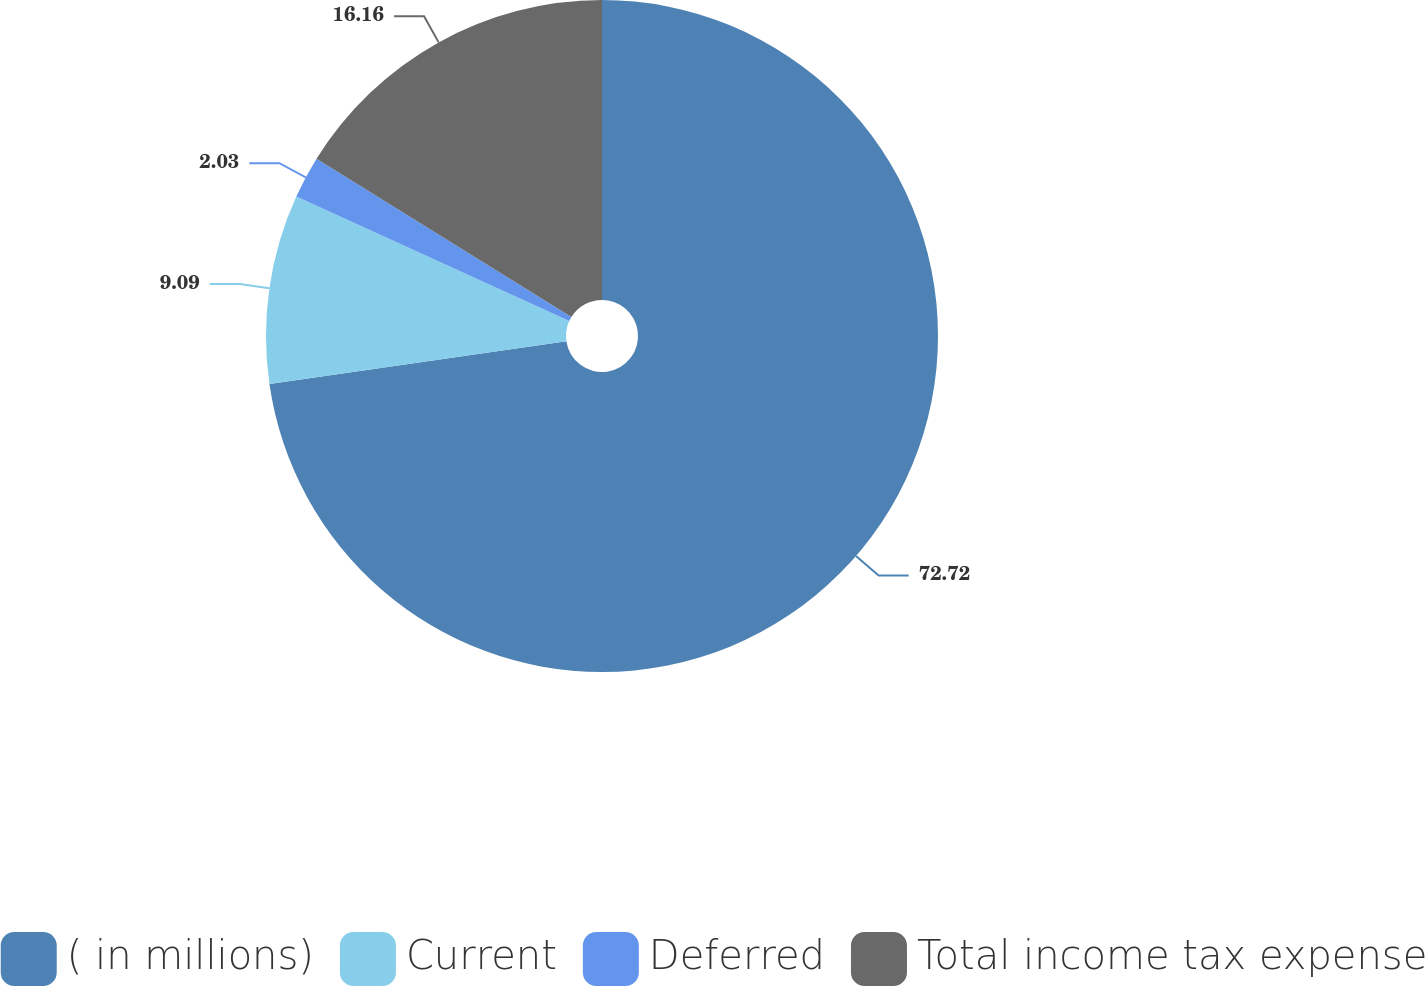<chart> <loc_0><loc_0><loc_500><loc_500><pie_chart><fcel>( in millions)<fcel>Current<fcel>Deferred<fcel>Total income tax expense<nl><fcel>72.72%<fcel>9.09%<fcel>2.03%<fcel>16.16%<nl></chart> 